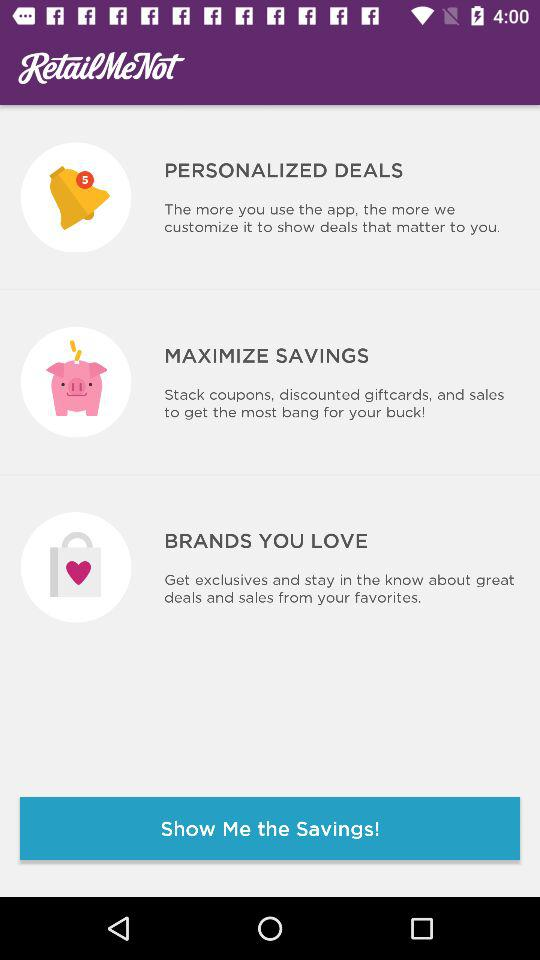What is the application name? The application name is "RetailMeNot". 